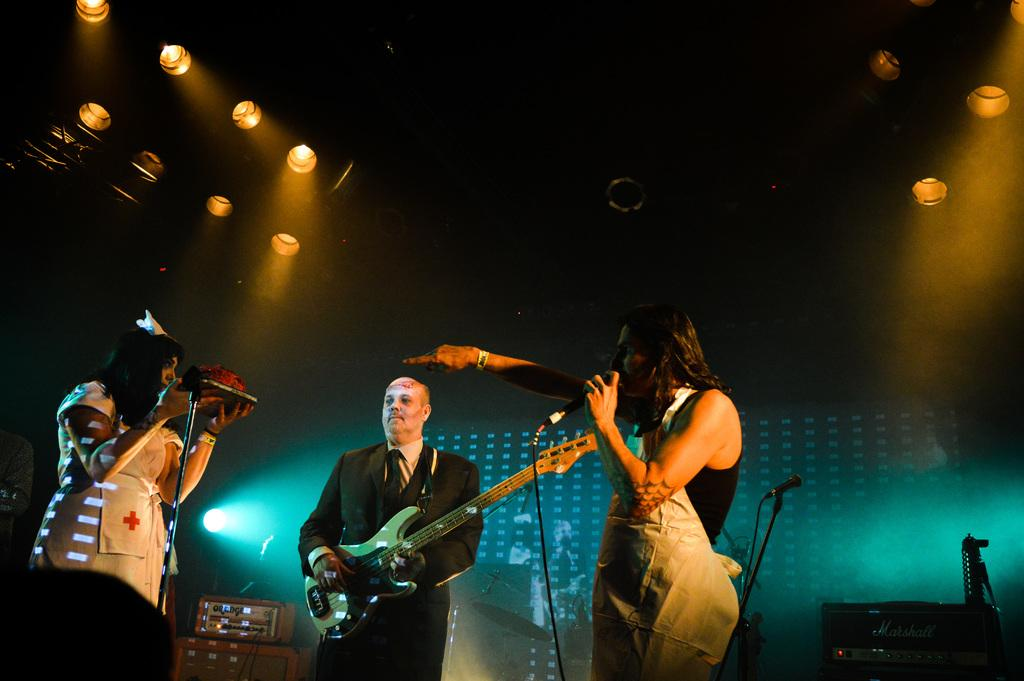What can be seen at the top of the image? There are lights visible at the top of the image. What are the persons in the image doing? The persons are standing in front of a microphone, singing, and playing a guitar. What type of device is present in the image? There is an electronic device present. What type of prose is being recited by the snails during dinner in the image? There are no snails or dinner present in the image, and therefore no such activity can be observed. 